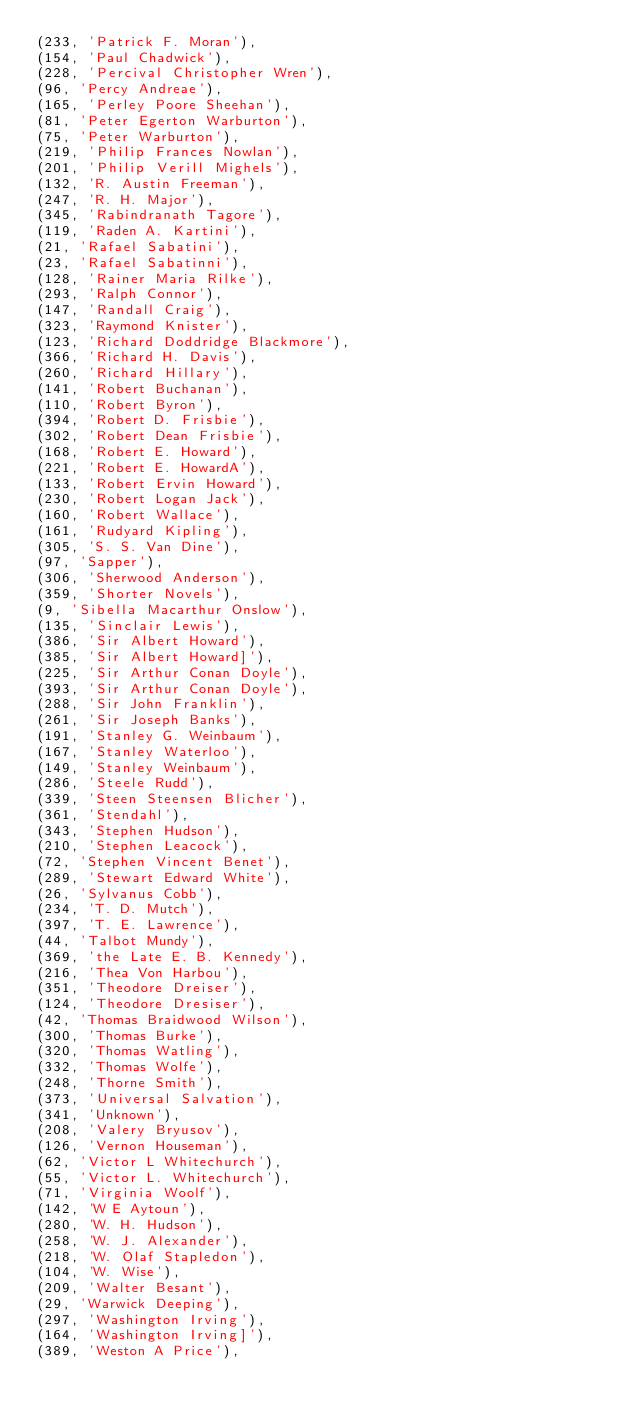Convert code to text. <code><loc_0><loc_0><loc_500><loc_500><_SQL_>(233, 'Patrick F. Moran'),
(154, 'Paul Chadwick'),
(228, 'Percival Christopher Wren'),
(96, 'Percy Andreae'),
(165, 'Perley Poore Sheehan'),
(81, 'Peter Egerton Warburton'),
(75, 'Peter Warburton'),
(219, 'Philip Frances Nowlan'),
(201, 'Philip Verill Mighels'),
(132, 'R. Austin Freeman'),
(247, 'R. H. Major'),
(345, 'Rabindranath Tagore'),
(119, 'Raden A. Kartini'),
(21, 'Rafael Sabatini'),
(23, 'Rafael Sabatinni'),
(128, 'Rainer Maria Rilke'),
(293, 'Ralph Connor'),
(147, 'Randall Craig'),
(323, 'Raymond Knister'),
(123, 'Richard Doddridge Blackmore'),
(366, 'Richard H. Davis'),
(260, 'Richard Hillary'),
(141, 'Robert Buchanan'),
(110, 'Robert Byron'),
(394, 'Robert D. Frisbie'),
(302, 'Robert Dean Frisbie'),
(168, 'Robert E. Howard'),
(221, 'Robert E. HowardA'),
(133, 'Robert Ervin Howard'),
(230, 'Robert Logan Jack'),
(160, 'Robert Wallace'),
(161, 'Rudyard Kipling'),
(305, 'S. S. Van Dine'),
(97, 'Sapper'),
(306, 'Sherwood Anderson'),
(359, 'Shorter Novels'),
(9, 'Sibella Macarthur Onslow'),
(135, 'Sinclair Lewis'),
(386, 'Sir Albert Howard'),
(385, 'Sir Albert Howard]'),
(225, 'Sir Arthur Conan Doyle'),
(393, 'Sir Arthur Conan Doyle'),
(288, 'Sir John Franklin'),
(261, 'Sir Joseph Banks'),
(191, 'Stanley G. Weinbaum'),
(167, 'Stanley Waterloo'),
(149, 'Stanley Weinbaum'),
(286, 'Steele Rudd'),
(339, 'Steen Steensen Blicher'),
(361, 'Stendahl'),
(343, 'Stephen Hudson'),
(210, 'Stephen Leacock'),
(72, 'Stephen Vincent Benet'),
(289, 'Stewart Edward White'),
(26, 'Sylvanus Cobb'),
(234, 'T. D. Mutch'),
(397, 'T. E. Lawrence'),
(44, 'Talbot Mundy'),
(369, 'the Late E. B. Kennedy'),
(216, 'Thea Von Harbou'),
(351, 'Theodore Dreiser'),
(124, 'Theodore Dresiser'),
(42, 'Thomas Braidwood Wilson'),
(300, 'Thomas Burke'),
(320, 'Thomas Watling'),
(332, 'Thomas Wolfe'),
(248, 'Thorne Smith'),
(373, 'Universal Salvation'),
(341, 'Unknown'),
(208, 'Valery Bryusov'),
(126, 'Vernon Houseman'),
(62, 'Victor L Whitechurch'),
(55, 'Victor L. Whitechurch'),
(71, 'Virginia Woolf'),
(142, 'W E Aytoun'),
(280, 'W. H. Hudson'),
(258, 'W. J. Alexander'),
(218, 'W. Olaf Stapledon'),
(104, 'W. Wise'),
(209, 'Walter Besant'),
(29, 'Warwick Deeping'),
(297, 'Washington Irving'),
(164, 'Washington Irving]'),
(389, 'Weston A Price'),</code> 